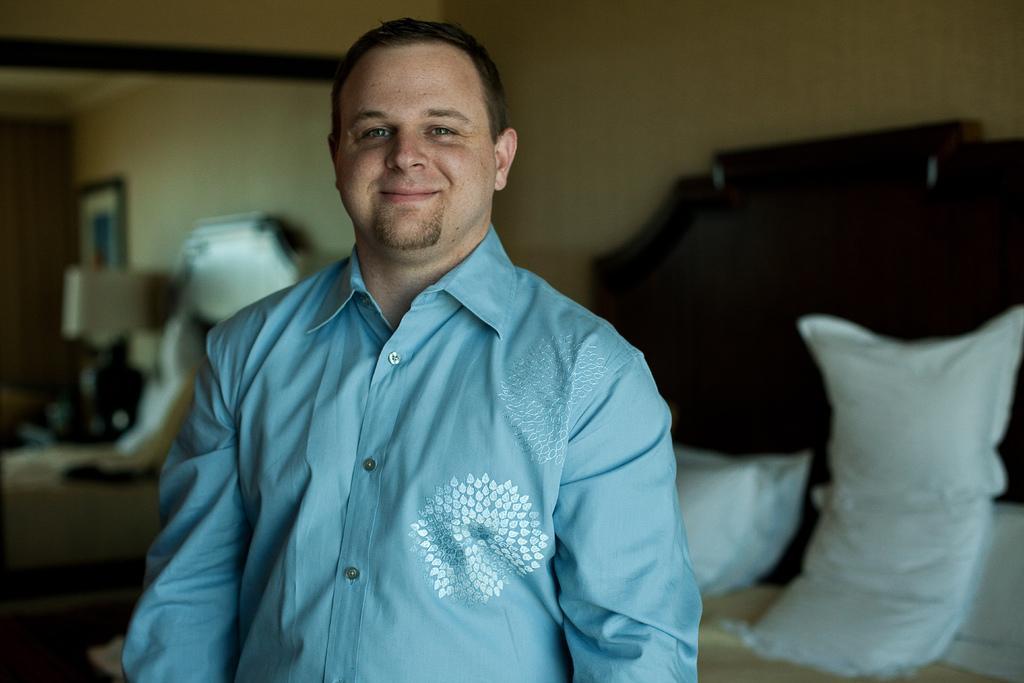Could you give a brief overview of what you see in this image? There is a man standing and smiling. We can see pillows on a bed. In the background it is blurry and we can see wall. 